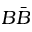<formula> <loc_0><loc_0><loc_500><loc_500>B \bar { B }</formula> 